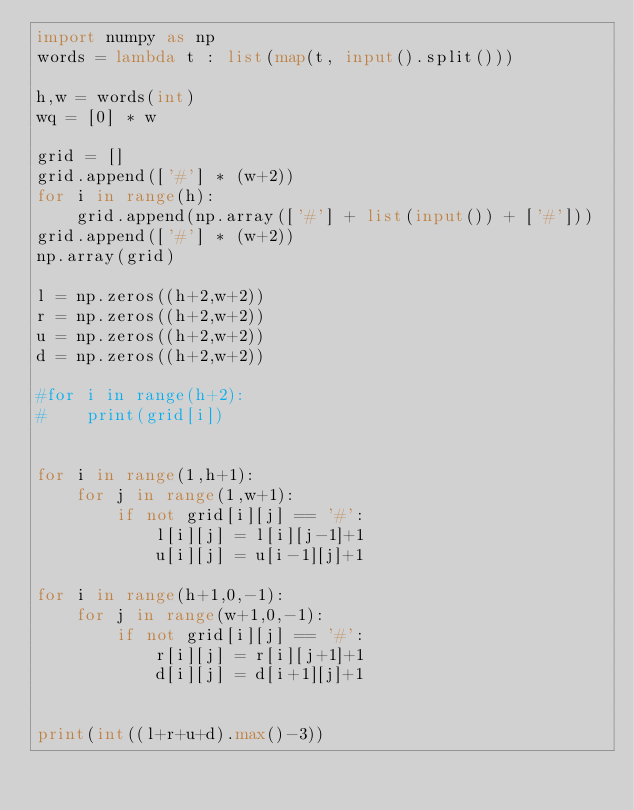<code> <loc_0><loc_0><loc_500><loc_500><_Python_>import numpy as np
words = lambda t : list(map(t, input().split()))

h,w = words(int)
wq = [0] * w

grid = []
grid.append(['#'] * (w+2))
for i in range(h):
    grid.append(np.array(['#'] + list(input()) + ['#']))
grid.append(['#'] * (w+2))
np.array(grid)

l = np.zeros((h+2,w+2))
r = np.zeros((h+2,w+2))
u = np.zeros((h+2,w+2))
d = np.zeros((h+2,w+2))

#for i in range(h+2):
#    print(grid[i])


for i in range(1,h+1):
    for j in range(1,w+1):
        if not grid[i][j] == '#':
            l[i][j] = l[i][j-1]+1
            u[i][j] = u[i-1][j]+1

for i in range(h+1,0,-1):
    for j in range(w+1,0,-1):
        if not grid[i][j] == '#':
            r[i][j] = r[i][j+1]+1
            d[i][j] = d[i+1][j]+1


print(int((l+r+u+d).max()-3))
</code> 